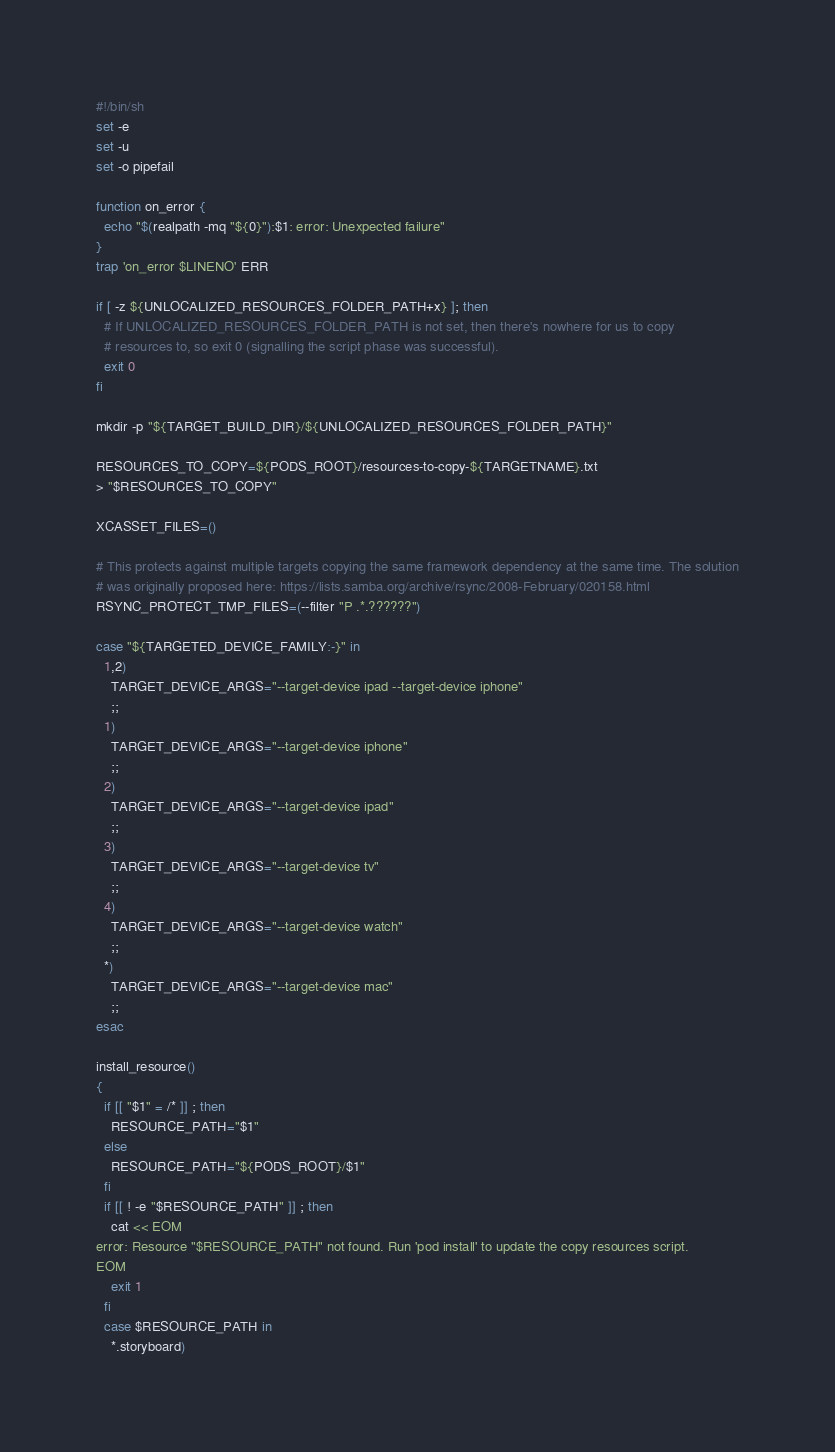Convert code to text. <code><loc_0><loc_0><loc_500><loc_500><_Bash_>#!/bin/sh
set -e
set -u
set -o pipefail

function on_error {
  echo "$(realpath -mq "${0}"):$1: error: Unexpected failure"
}
trap 'on_error $LINENO' ERR

if [ -z ${UNLOCALIZED_RESOURCES_FOLDER_PATH+x} ]; then
  # If UNLOCALIZED_RESOURCES_FOLDER_PATH is not set, then there's nowhere for us to copy
  # resources to, so exit 0 (signalling the script phase was successful).
  exit 0
fi

mkdir -p "${TARGET_BUILD_DIR}/${UNLOCALIZED_RESOURCES_FOLDER_PATH}"

RESOURCES_TO_COPY=${PODS_ROOT}/resources-to-copy-${TARGETNAME}.txt
> "$RESOURCES_TO_COPY"

XCASSET_FILES=()

# This protects against multiple targets copying the same framework dependency at the same time. The solution
# was originally proposed here: https://lists.samba.org/archive/rsync/2008-February/020158.html
RSYNC_PROTECT_TMP_FILES=(--filter "P .*.??????")

case "${TARGETED_DEVICE_FAMILY:-}" in
  1,2)
    TARGET_DEVICE_ARGS="--target-device ipad --target-device iphone"
    ;;
  1)
    TARGET_DEVICE_ARGS="--target-device iphone"
    ;;
  2)
    TARGET_DEVICE_ARGS="--target-device ipad"
    ;;
  3)
    TARGET_DEVICE_ARGS="--target-device tv"
    ;;
  4)
    TARGET_DEVICE_ARGS="--target-device watch"
    ;;
  *)
    TARGET_DEVICE_ARGS="--target-device mac"
    ;;
esac

install_resource()
{
  if [[ "$1" = /* ]] ; then
    RESOURCE_PATH="$1"
  else
    RESOURCE_PATH="${PODS_ROOT}/$1"
  fi
  if [[ ! -e "$RESOURCE_PATH" ]] ; then
    cat << EOM
error: Resource "$RESOURCE_PATH" not found. Run 'pod install' to update the copy resources script.
EOM
    exit 1
  fi
  case $RESOURCE_PATH in
    *.storyboard)</code> 